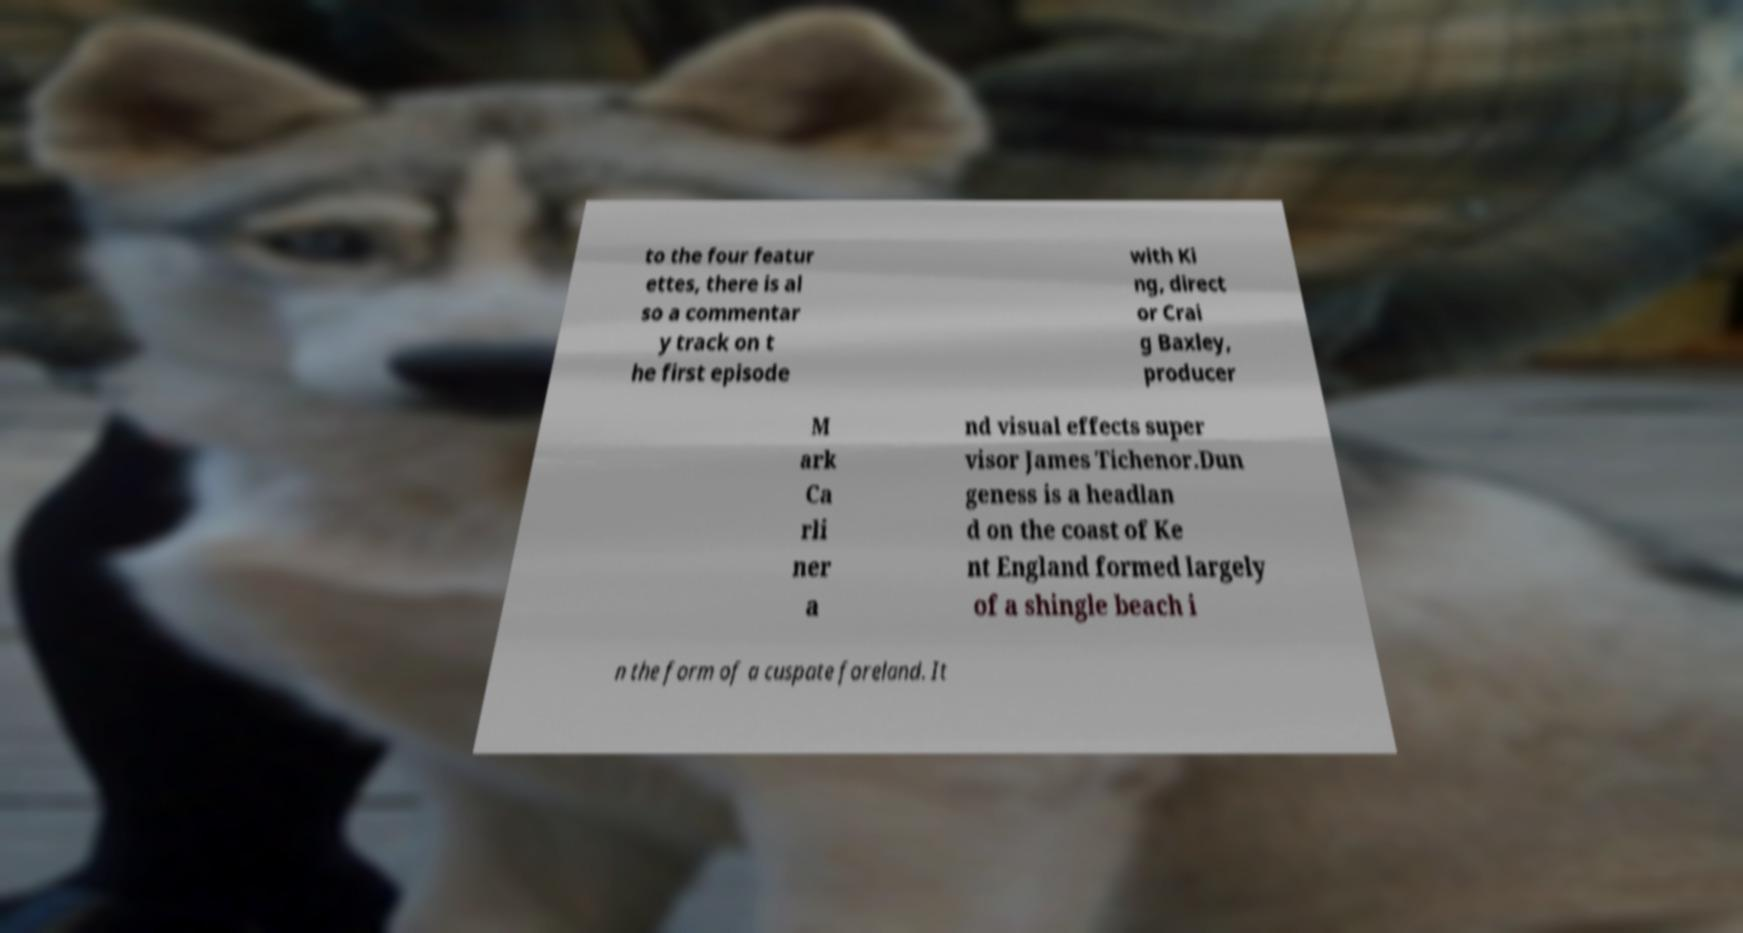Please identify and transcribe the text found in this image. to the four featur ettes, there is al so a commentar y track on t he first episode with Ki ng, direct or Crai g Baxley, producer M ark Ca rli ner a nd visual effects super visor James Tichenor.Dun geness is a headlan d on the coast of Ke nt England formed largely of a shingle beach i n the form of a cuspate foreland. It 